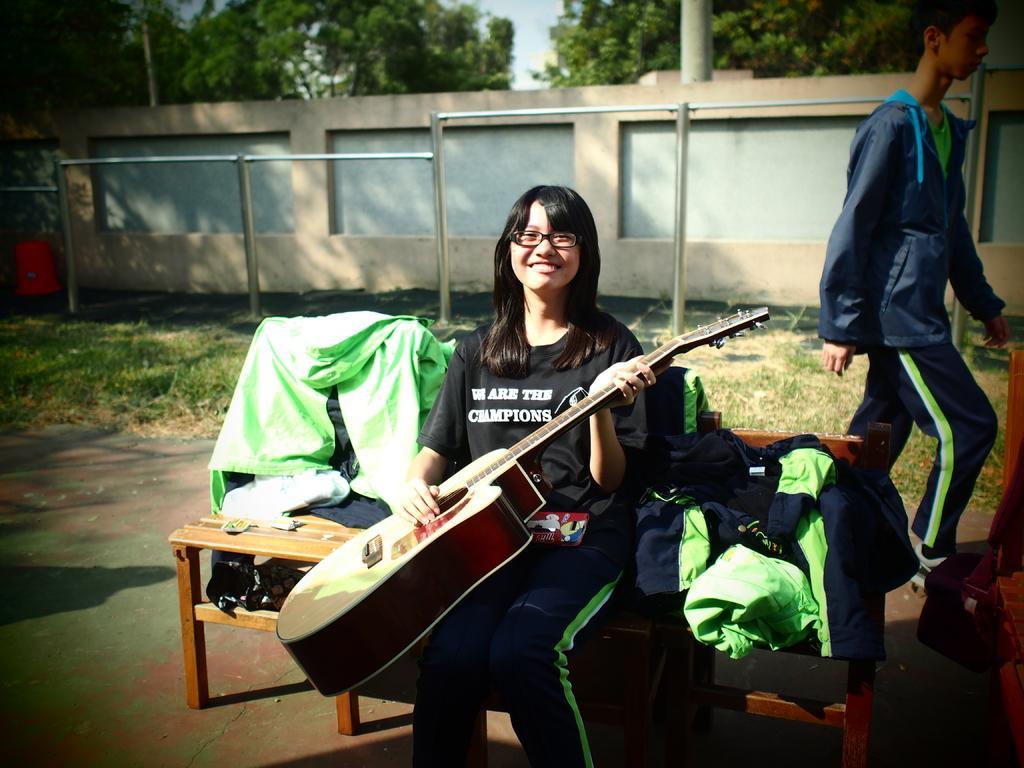How would you summarize this image in a sentence or two? In the image we can see there is a woman who is sitting on chair and holding guitar in her hand and at the back there is a man who is standing. 